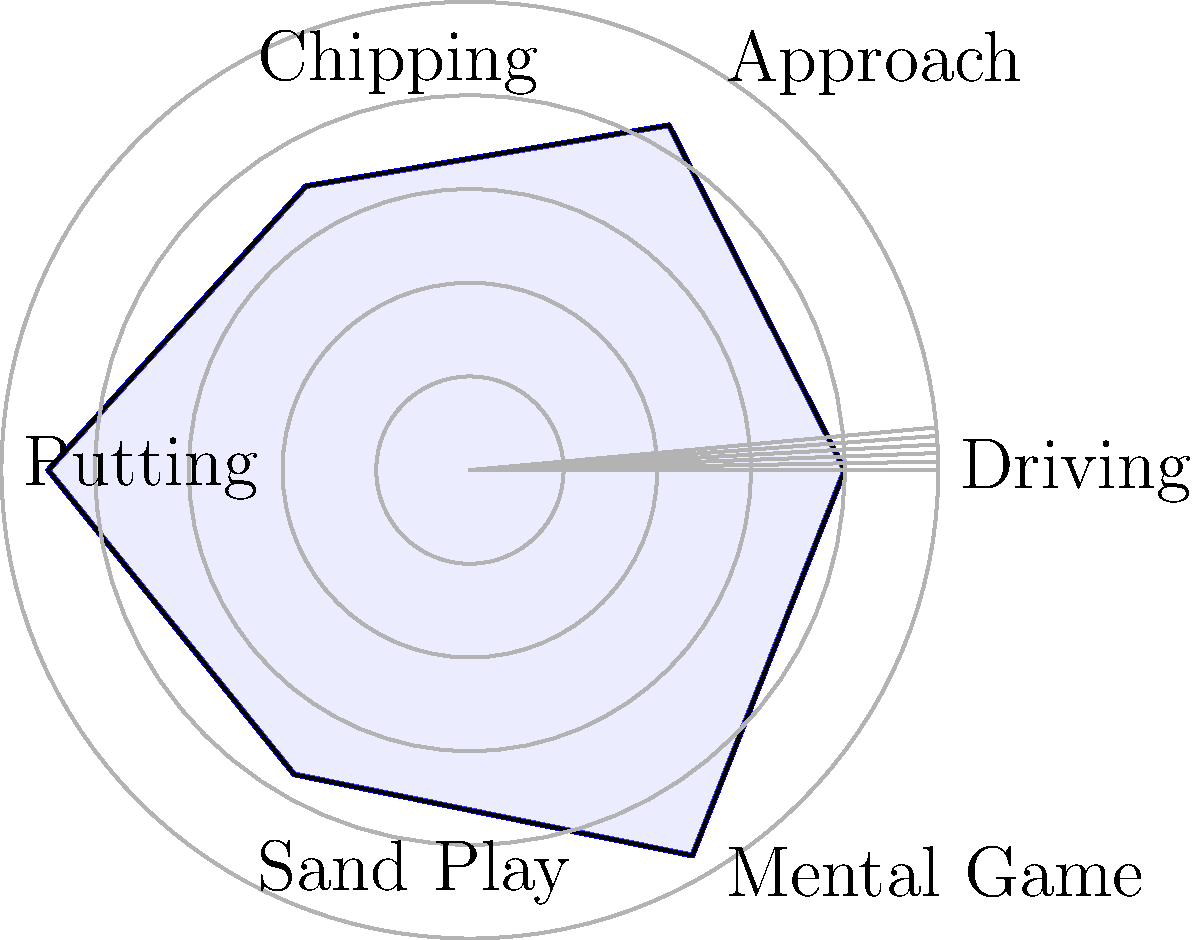As a golf application developer, you're analyzing a radar chart showing a professional golfer's skill metrics. The chart displays six categories: Driving, Approach, Chipping, Putting, Sand Play, and Mental Game, each scored on a scale from 0 to 100. What is the golfer's strongest skill, and by how many points does it exceed their weakest skill? To answer this question, we need to follow these steps:

1. Identify the highest (strongest) and lowest (weakest) scores on the radar chart.
2. Calculate the difference between these scores.

Analyzing the radar chart:

1. Driving: 80
2. Approach: 85
3. Chipping: 70
4. Putting: 90
5. Sand Play: 75
6. Mental Game: 95

The highest score is 95 for the Mental Game, making it the golfer's strongest skill.
The lowest score is 70 for Chipping, making it the golfer's weakest skill.

To calculate the difference:
$95 - 70 = 25$

Therefore, the golfer's strongest skill (Mental Game) exceeds their weakest skill (Chipping) by 25 points.
Answer: Mental Game; 25 points 